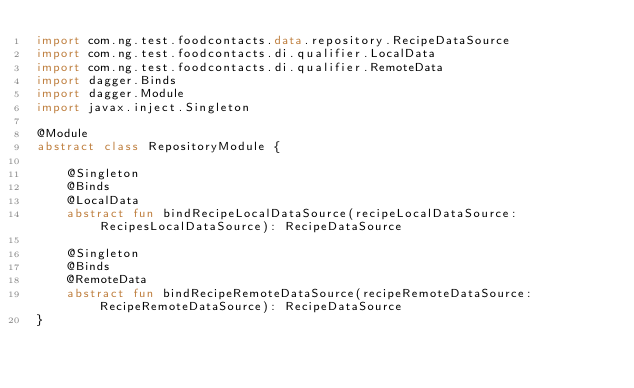Convert code to text. <code><loc_0><loc_0><loc_500><loc_500><_Kotlin_>import com.ng.test.foodcontacts.data.repository.RecipeDataSource
import com.ng.test.foodcontacts.di.qualifier.LocalData
import com.ng.test.foodcontacts.di.qualifier.RemoteData
import dagger.Binds
import dagger.Module
import javax.inject.Singleton

@Module
abstract class RepositoryModule {

    @Singleton
    @Binds
    @LocalData
    abstract fun bindRecipeLocalDataSource(recipeLocalDataSource: RecipesLocalDataSource): RecipeDataSource

    @Singleton
    @Binds
    @RemoteData
    abstract fun bindRecipeRemoteDataSource(recipeRemoteDataSource: RecipeRemoteDataSource): RecipeDataSource
}</code> 